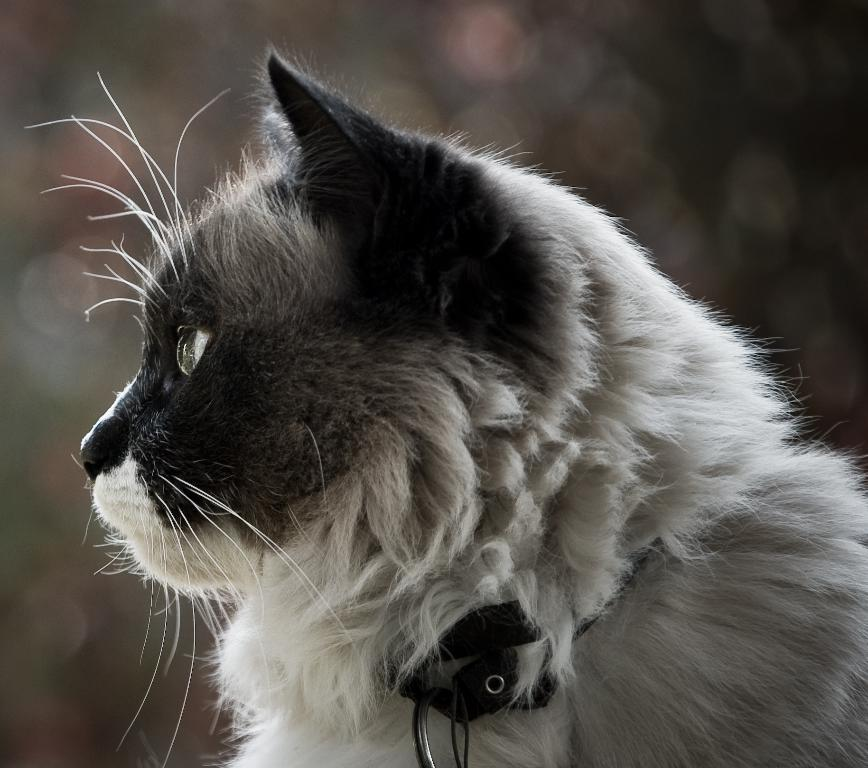What type of animal is in the image? There is a cat in the image. What is the cat wearing? The cat is wearing a belt. Can you describe the background of the image? The background of the image is blurred. How many dolls are sitting on the plate in the image? There are no dolls or plates present in the image; it features a cat wearing a belt with a blurred background. 